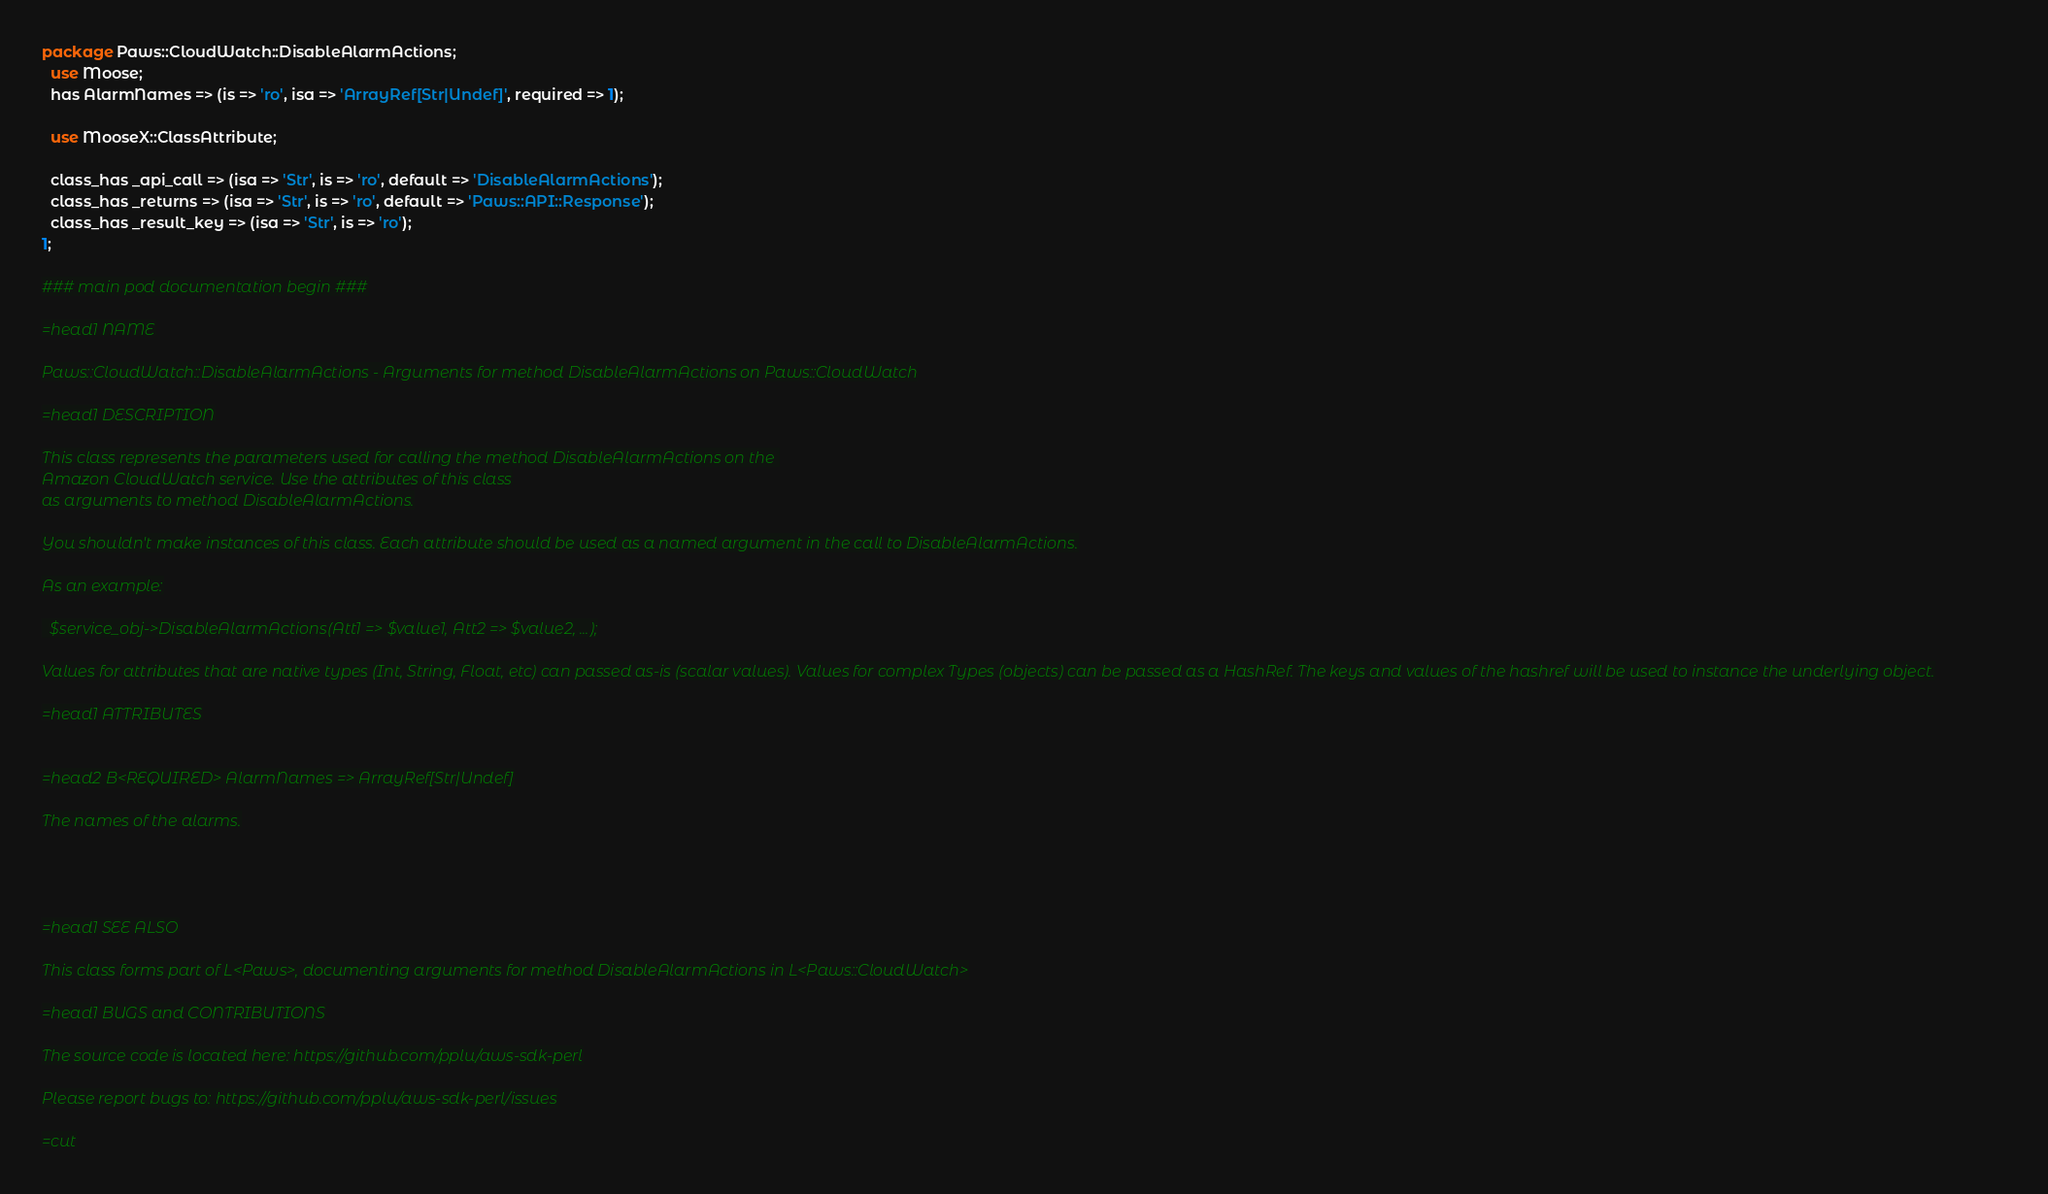Convert code to text. <code><loc_0><loc_0><loc_500><loc_500><_Perl_>
package Paws::CloudWatch::DisableAlarmActions;
  use Moose;
  has AlarmNames => (is => 'ro', isa => 'ArrayRef[Str|Undef]', required => 1);

  use MooseX::ClassAttribute;

  class_has _api_call => (isa => 'Str', is => 'ro', default => 'DisableAlarmActions');
  class_has _returns => (isa => 'Str', is => 'ro', default => 'Paws::API::Response');
  class_has _result_key => (isa => 'Str', is => 'ro');
1;

### main pod documentation begin ###

=head1 NAME

Paws::CloudWatch::DisableAlarmActions - Arguments for method DisableAlarmActions on Paws::CloudWatch

=head1 DESCRIPTION

This class represents the parameters used for calling the method DisableAlarmActions on the 
Amazon CloudWatch service. Use the attributes of this class
as arguments to method DisableAlarmActions.

You shouldn't make instances of this class. Each attribute should be used as a named argument in the call to DisableAlarmActions.

As an example:

  $service_obj->DisableAlarmActions(Att1 => $value1, Att2 => $value2, ...);

Values for attributes that are native types (Int, String, Float, etc) can passed as-is (scalar values). Values for complex Types (objects) can be passed as a HashRef. The keys and values of the hashref will be used to instance the underlying object.

=head1 ATTRIBUTES


=head2 B<REQUIRED> AlarmNames => ArrayRef[Str|Undef]

The names of the alarms.




=head1 SEE ALSO

This class forms part of L<Paws>, documenting arguments for method DisableAlarmActions in L<Paws::CloudWatch>

=head1 BUGS and CONTRIBUTIONS

The source code is located here: https://github.com/pplu/aws-sdk-perl

Please report bugs to: https://github.com/pplu/aws-sdk-perl/issues

=cut

</code> 